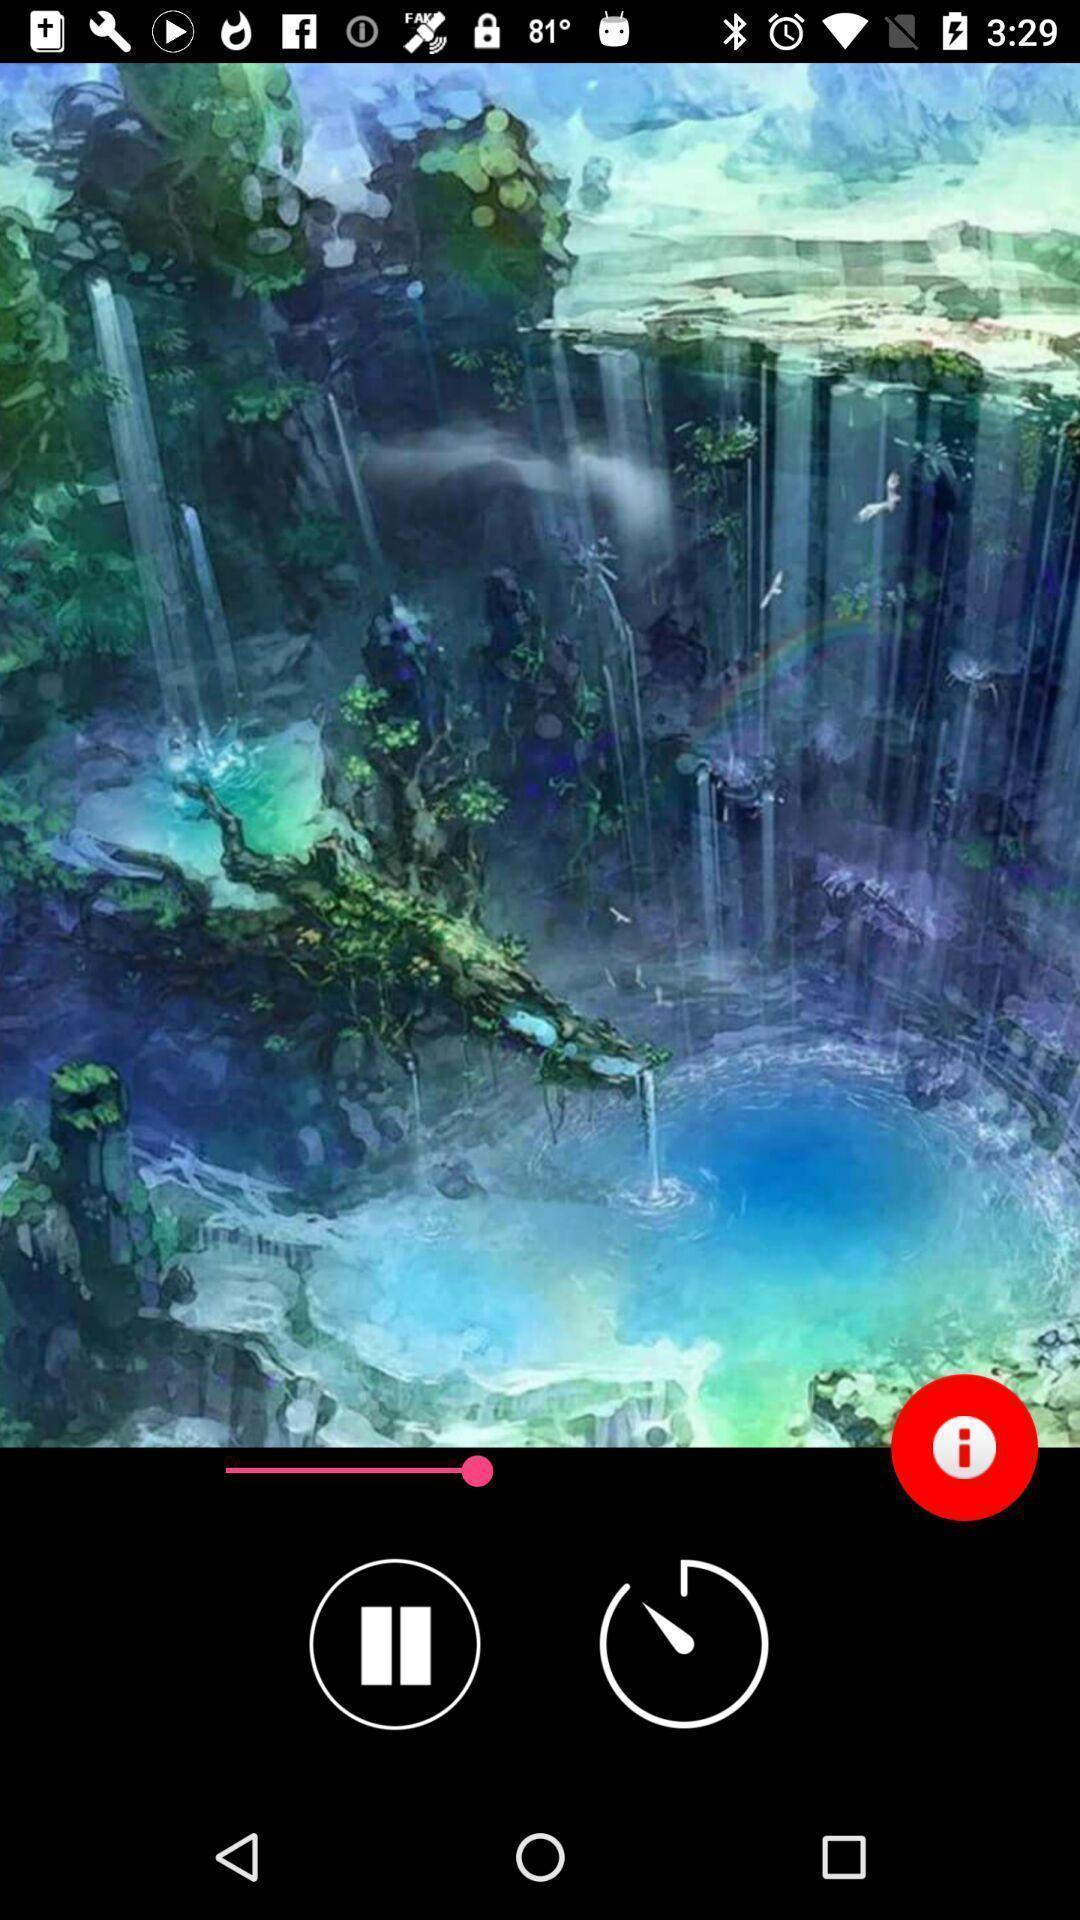Describe the content in this image. Screen displaying video in video player app. 